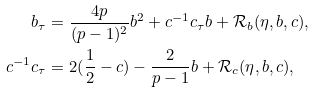<formula> <loc_0><loc_0><loc_500><loc_500>b _ { \tau } & = \frac { 4 p } { ( p - 1 ) ^ { 2 } } b ^ { 2 } + c ^ { - 1 } c _ { \tau } b + { \mathcal { R } } _ { b } ( \eta , b , c ) , \\ c ^ { - 1 } c _ { \tau } & = 2 ( \frac { 1 } { 2 } - c ) - \frac { 2 } { p - 1 } b + { \mathcal { R } } _ { c } ( \eta , b , c ) ,</formula> 